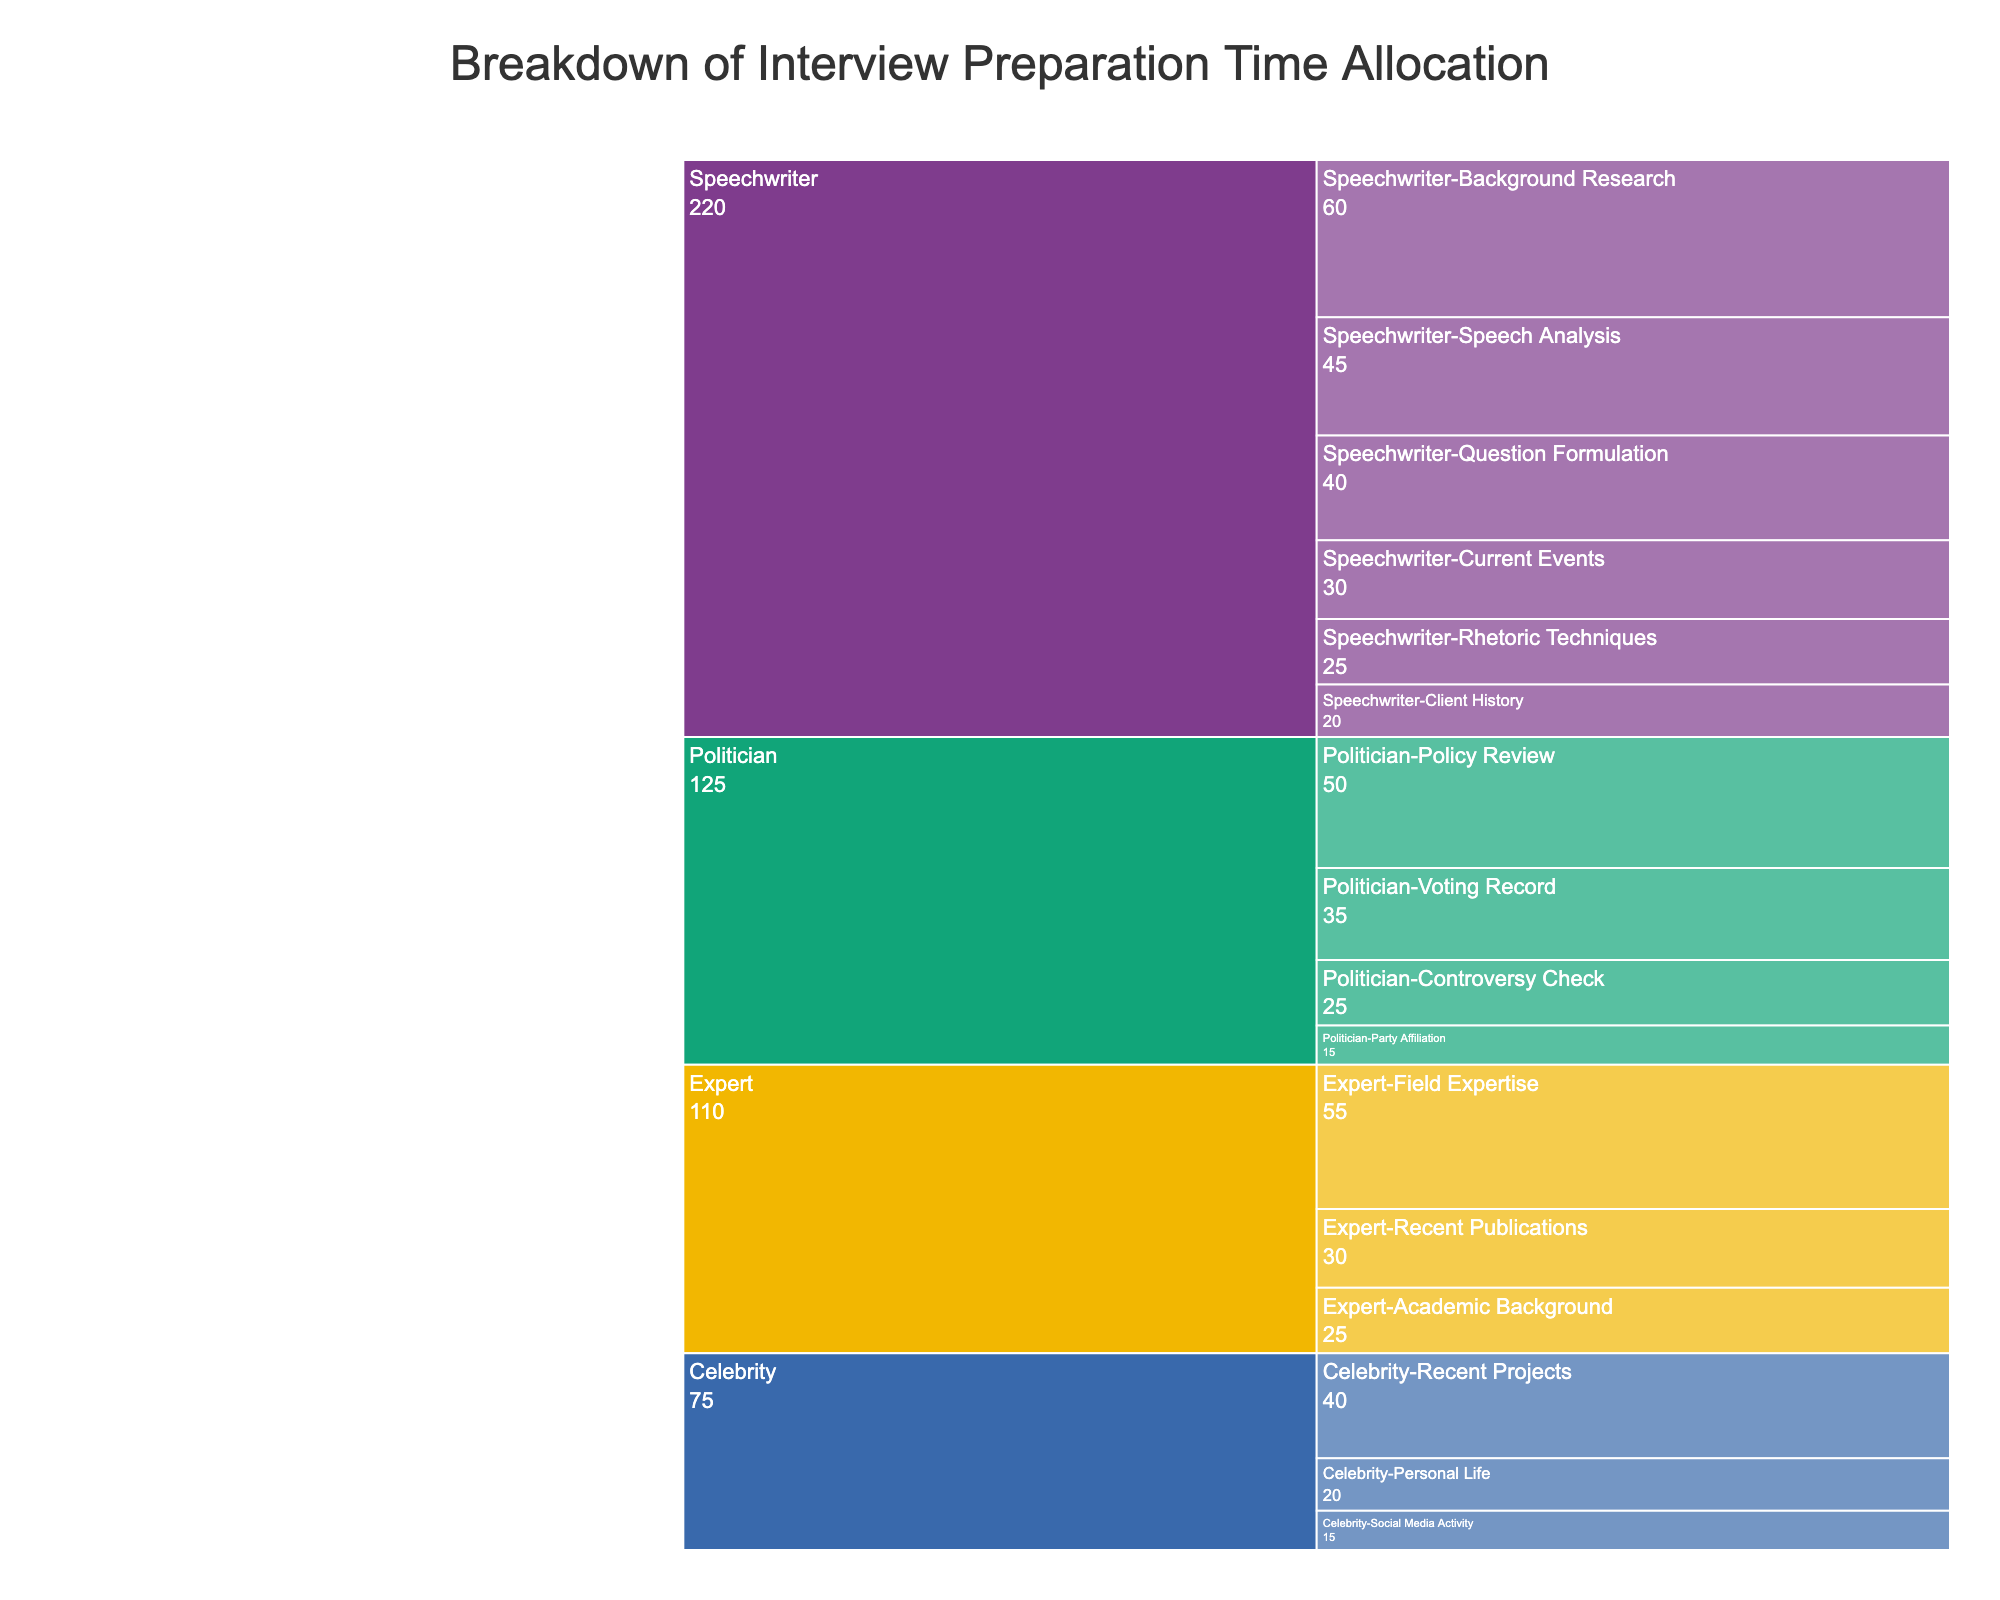How much time is allocated to background research for the speechwriter? The chart shows "Background Research" as one of the preparation areas under the speechwriter's category with a specific time allocation.
Answer: 60 minutes Which interviewee type has the highest total preparation time listed in the chart? We need to sum the preparation times for each interviewee type and compare them. For the speechwriter, it's 60 + 45 + 30 + 40 + 25 + 20 = 220 minutes. For the politician, it's 50 + 35 + 25 + 15 = 125 minutes. For the celebrity, it's 40 + 20 + 15 = 75 minutes. For the expert, it's 55 + 30 + 25 = 110 minutes.
Answer: Speechwriter What is the difference in time allocation for “Policy Review” compared to “Speech Analysis”? Find the time for "Policy Review" under the politician category (50 minutes) and compare it to the time for "Speech Analysis" under the speechwriter category (45 minutes).
Answer: 5 minutes Which preparation area under experts takes the least amount of time? Check the preparation areas listed for the expert category and their corresponding times: "Field Expertise" (55 minutes), "Recent Publications" (30 minutes), "Academic Background" (25 minutes).
Answer: Academic Background How much total time is spent on question formulation and rhetoric techniques for the speechwriter? Add the time allocated for "Question Formulation" (40 minutes) and "Rhetoric Techniques" (25 minutes) under the speechwriter's category.
Answer: 65 minutes Compare the total preparation time for experts to that for politicians. Sum the times for the expert category (55 + 30 + 25 = 110 minutes) and the politician category (50 + 35 + 25 + 15 = 125 minutes) and compare them.
Answer: Politicians have more time Which interviewee type has the lowest single time allocation in any preparation area? Identify the smallest single time allocation across all preparation areas and categories: "Client History" for speechwriters (20 minutes), "Party Affiliation" for politicians (15 minutes), "Social Media Activity" for celebrities (15 minutes), and "Academic Background" for experts (25 minutes).
Answer: Politician and Celebrity (tie) What is the average time allocation for all preparation areas under the politician interviewee type? Calculate the total time for preparation areas under the politician (50 + 35 + 25 + 15 = 125 minutes) and divide by the number of areas (4).
Answer: 31.25 minutes 